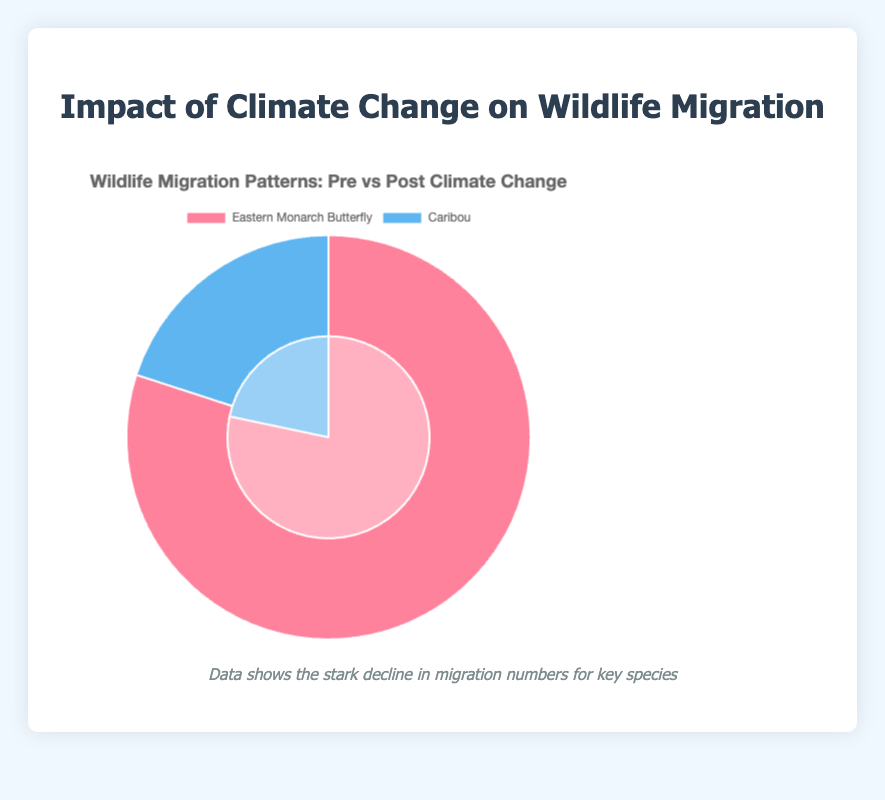What is the total migration count for the Eastern Monarch Butterfly and Caribou pre-climate change? To find the total migration count pre-climate change, sum the migration counts of the Eastern Monarch Butterfly (1,000,000) and Caribou (250,000). The calculation is 1,000,000 + 250,000 = 1,250,000
Answer: 1,250,000 What is the difference in the migration count of the Eastern Monarch Butterfly pre and post-climate change? Subtract the post-climate change migration count (650,000) from the pre-climate change migration count (1,000,000). The calculation is 1,000,000 - 650,000 = 350,000
Answer: 350,000 Which species experienced a greater reduction in their migration count due to climate change? Compare the difference in the migration counts pre and post-climate change for both species. Eastern Monarch Butterfly decreased by 350,000 (1,000,000 - 650,000) and Caribou decreased by 70,000 (250,000 - 180,000). Since 350,000 > 70,000, the Eastern Monarch Butterfly experienced a greater reduction.
Answer: Eastern Monarch Butterfly What percentage decrease did the Caribou experience post-climate change? Calculate the percentage decrease by dividing the difference in migration counts by the pre-climate change count and then multiply by 100. The difference is 70,000 (250,000 - 180,000). Calculation: (70,000 / 250,000) * 100 = 28%
Answer: 28% What does the section for the Eastern Monarch Butterfly look like on the pie chart? The section for the Eastern Monarch Butterfly is represented with red hues; a darker shade for pre-climate change (highlighting 1,000,000) and a lighter shade for post-climate change (highlighting 650,000).
Answer: Red hues Which species had a larger absolute migration count change due to climate change? Find the absolute change for both species and compare them. The Eastern Monarch Butterfly had an absolute change of 350,000 (1,000,000 - 650,000), and the Caribou had an absolute change of 70,000 (250,000 - 180,000). Since 350,000 > 70,000, the Eastern Monarch Butterfly had a larger absolute migration count change.
Answer: Eastern Monarch Butterfly What is the combined post-climate change migration count for both species? Sum the post-climate change migration counts of the Eastern Monarch Butterfly (650,000) and Caribou (180,000). The calculation is 650,000 + 180,000 = 830,000
Answer: 830,000 Which color represents the Caribou's data in the pie chart? The Caribou's data is represented by blue hues; a darker blue for pre-climate change (highlighting 250,000) and a lighter blue for post-climate change (highlighting 180,000).
Answer: Blue How much more did the Eastern Monarch Butterfly migrate pre-climate change compared to post-climate change? To find how much more the Eastern Monarch Butterfly migrated pre-climate change, subtract the post-climate change migration count (650,000) from the pre-climate change count (1,000,000). The calculation is 1,000,000 - 650,000 = 350,000
Answer: 350,000 By what percentage did the Eastern Monarch Butterfly's migration decrease post-climate change? Calculate the percentage decrease by dividing the difference in migration counts by the pre-climate change count, then multiply by 100. The difference is 350,000 (1,000,000 - 650,000). Calculation: (350,000 / 1,000,000) * 100 = 35%
Answer: 35% 